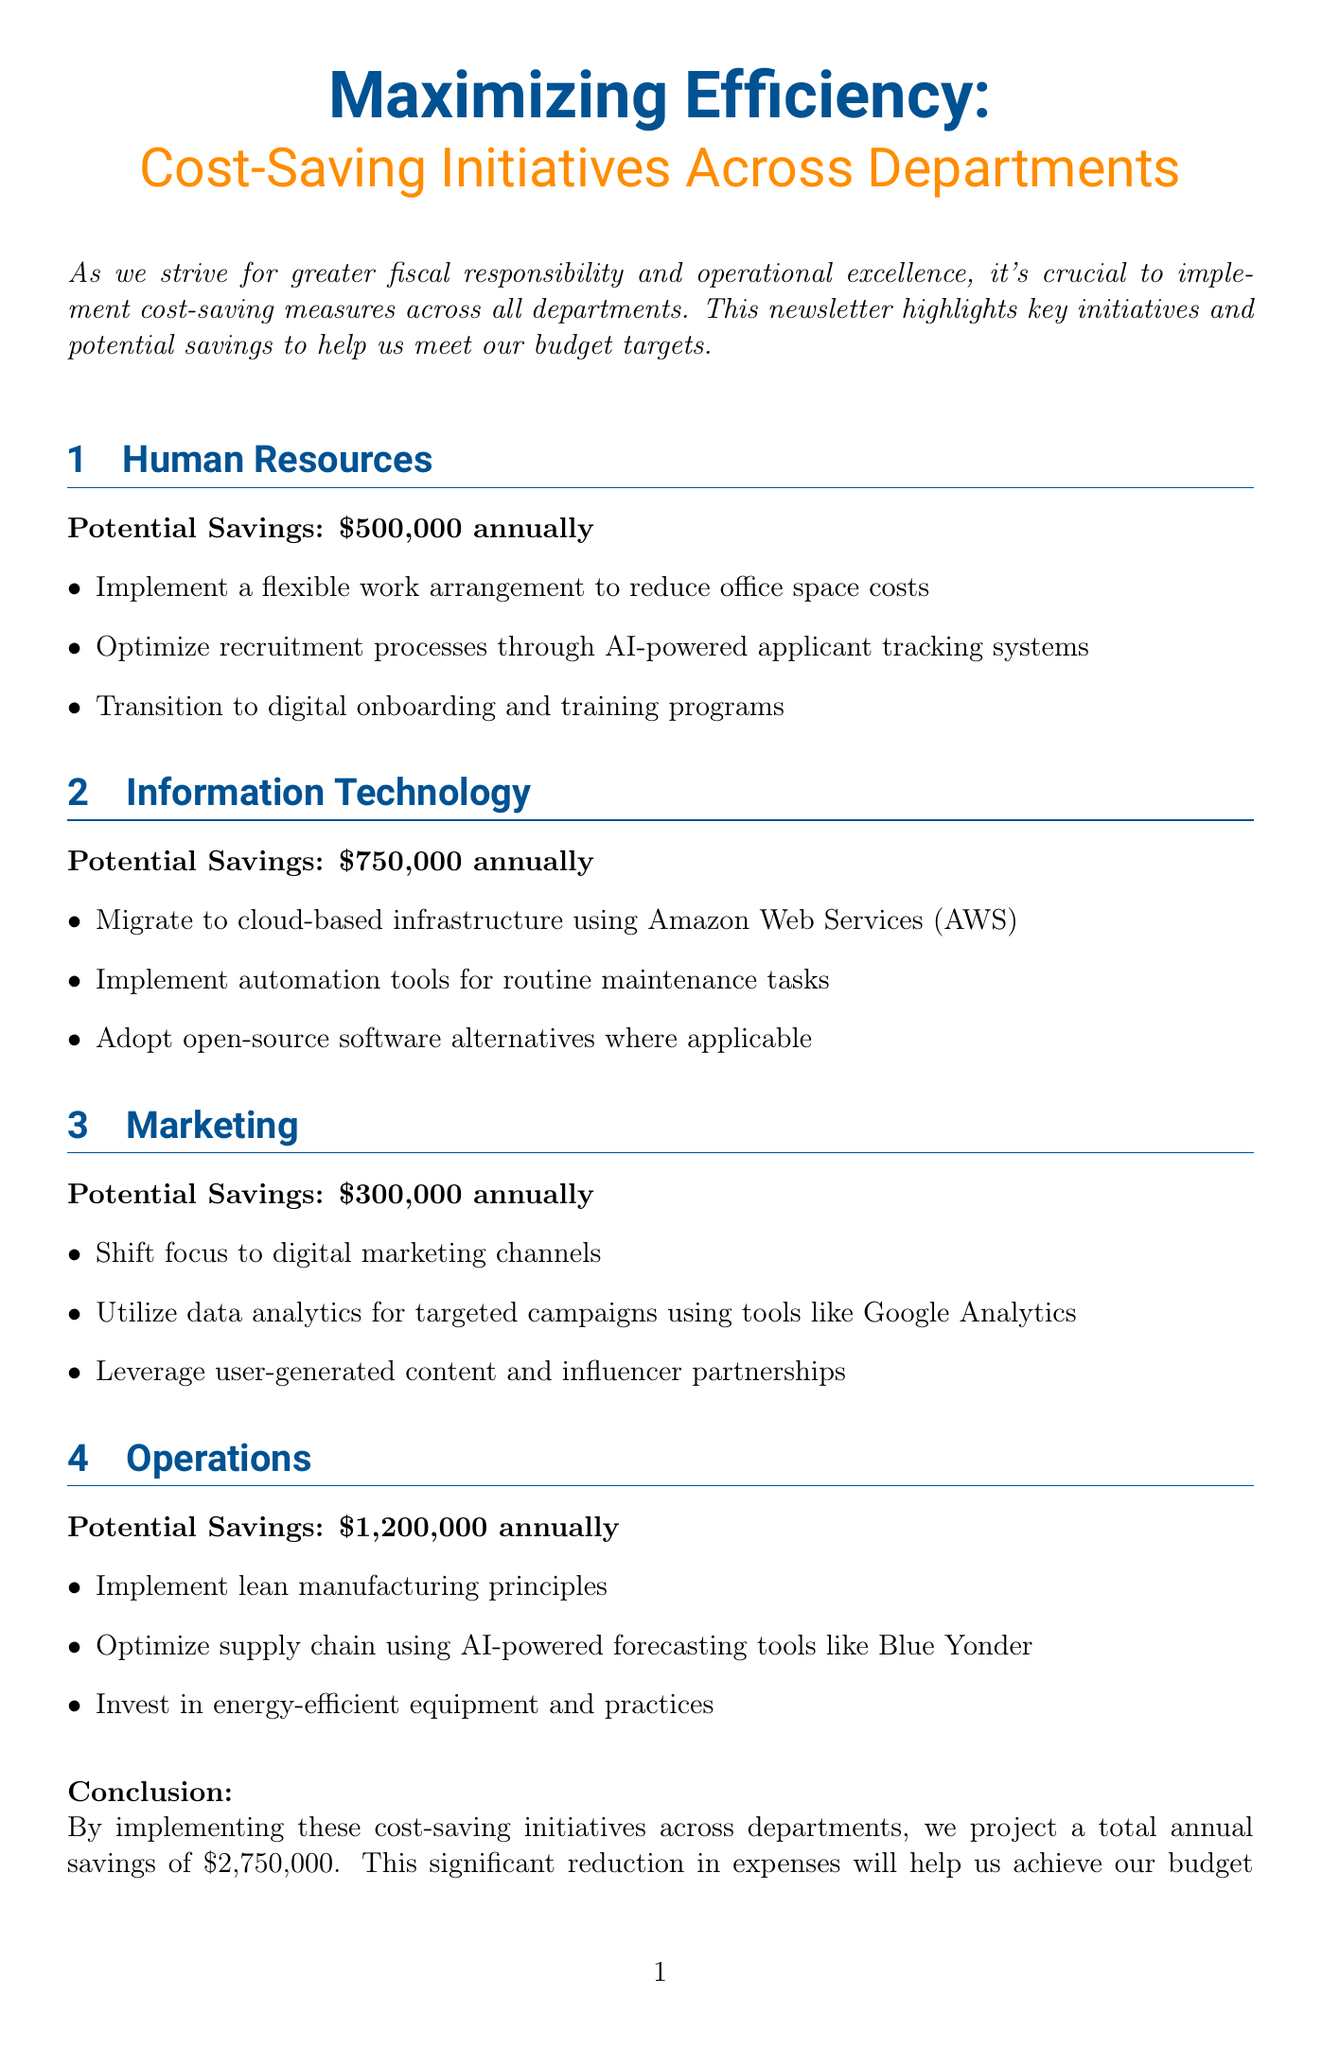What is the title of the newsletter? The title is provided at the beginning of the document.
Answer: Maximizing Efficiency: Cost-Saving Initiatives Across Departments How much potential savings does the HR department project annually? The potential savings for HR is specified directly in the document.
Answer: $500,000 annually Which department is projected to save the most money? The document lists the potential savings for each department, allowing for comparison.
Answer: Operations What is the total projected savings across all departments? The total projected savings is summarized in the conclusion of the document.
Answer: $2,750,000 What type of chart is used for the IT cost reduction strategy? The infographic data specified the type of chart for the IT section.
Answer: Bar chart Which tool is suggested for optimizing recruitment processes in HR? The document mentions specific tools or practices for each department's initiatives.
Answer: AI-powered applicant tracking systems What initiative is mentioned for Marketing to leverage user engagement? The specific initiative is noted in the marketing section discussing how to engage customers.
Answer: Influencer partnerships What is one of the initiatives for cost savings in the Operations department? The document lists initiatives aimed at saving costs within the Operations section.
Answer: Lean manufacturing principles Which color is used for the section headers in the newsletter? The format specifications indicate the colors used in the document styling.
Answer: Primary color 